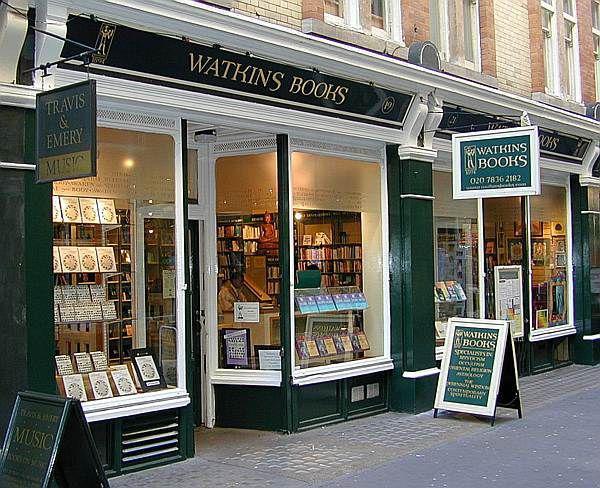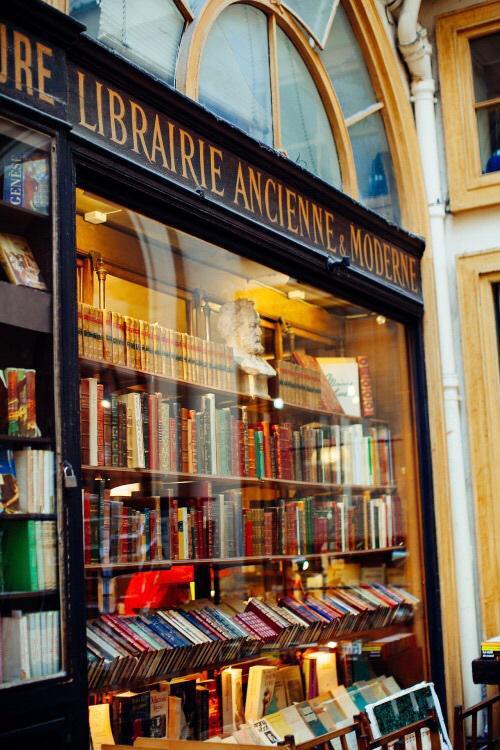The first image is the image on the left, the second image is the image on the right. Analyze the images presented: Is the assertion "In one image a bookstore with its entrance located between two large window areas has at least one advertising placard on the sidewalk in front." valid? Answer yes or no. Yes. 